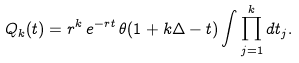Convert formula to latex. <formula><loc_0><loc_0><loc_500><loc_500>Q _ { k } ( t ) = r ^ { k } \, e ^ { - r t } \, \theta ( 1 + k \Delta - t ) \int \prod _ { j = 1 } ^ { k } d t _ { j } .</formula> 